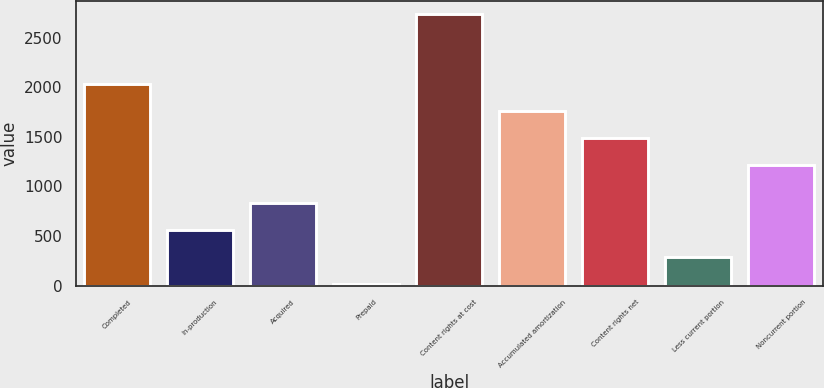Convert chart. <chart><loc_0><loc_0><loc_500><loc_500><bar_chart><fcel>Completed<fcel>In-production<fcel>Acquired<fcel>Prepaid<fcel>Content rights at cost<fcel>Accumulated amortization<fcel>Content rights net<fcel>Less current portion<fcel>Noncurrent portion<nl><fcel>2033.9<fcel>557.6<fcel>829.9<fcel>13<fcel>2736<fcel>1761.6<fcel>1489.3<fcel>285.3<fcel>1217<nl></chart> 